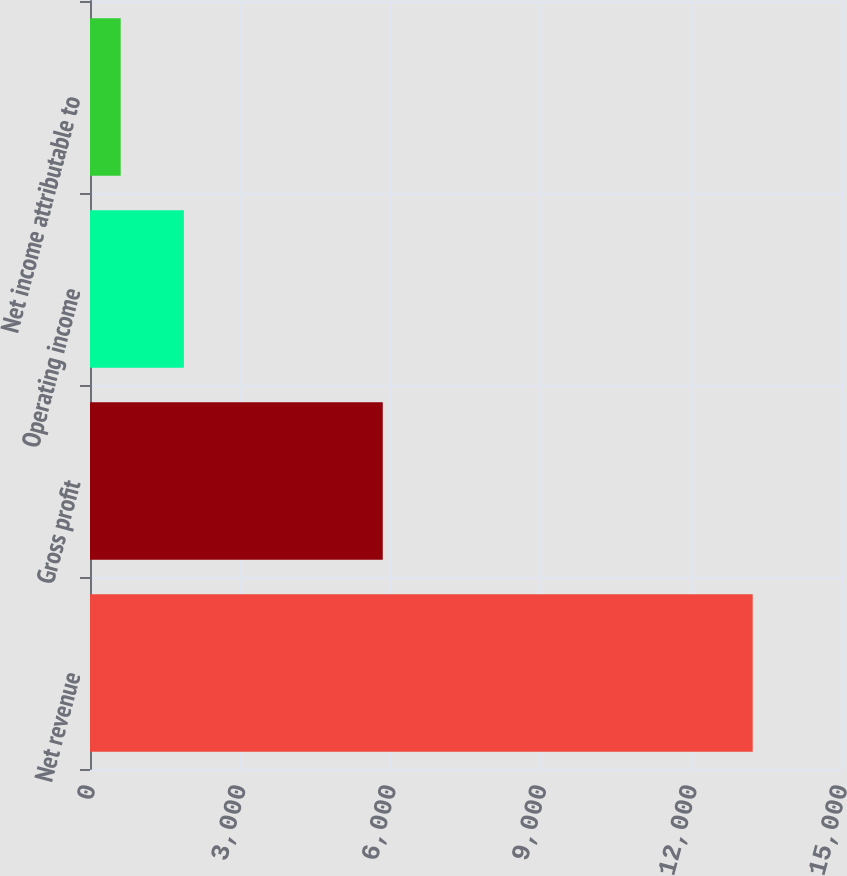Convert chart to OTSL. <chart><loc_0><loc_0><loc_500><loc_500><bar_chart><fcel>Net revenue<fcel>Gross profit<fcel>Operating income<fcel>Net income attributable to<nl><fcel>13219<fcel>5840<fcel>1872.7<fcel>612<nl></chart> 